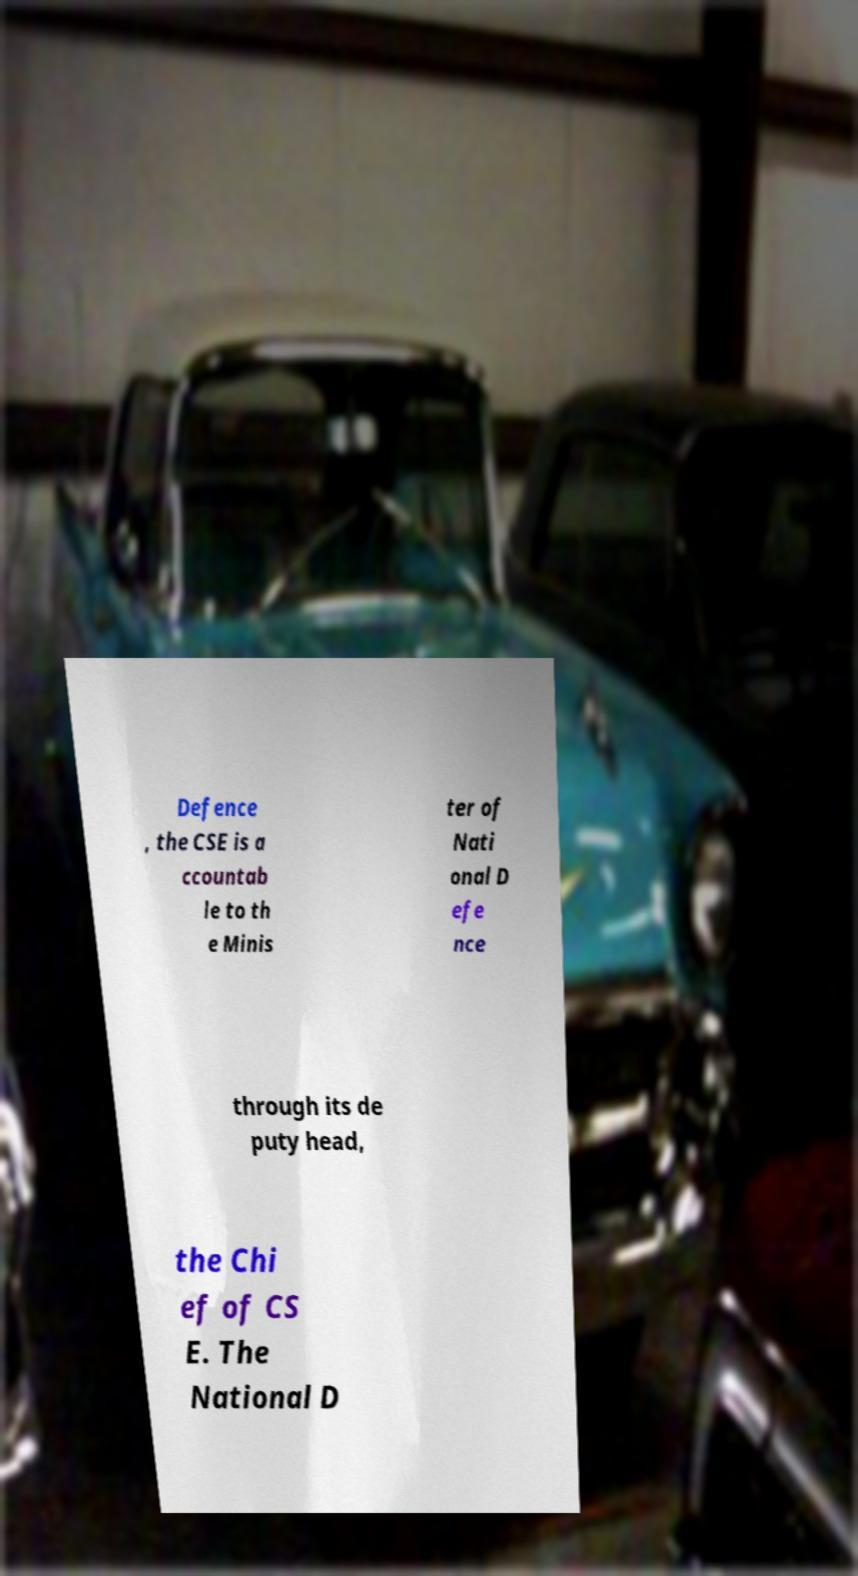Can you accurately transcribe the text from the provided image for me? Defence , the CSE is a ccountab le to th e Minis ter of Nati onal D efe nce through its de puty head, the Chi ef of CS E. The National D 